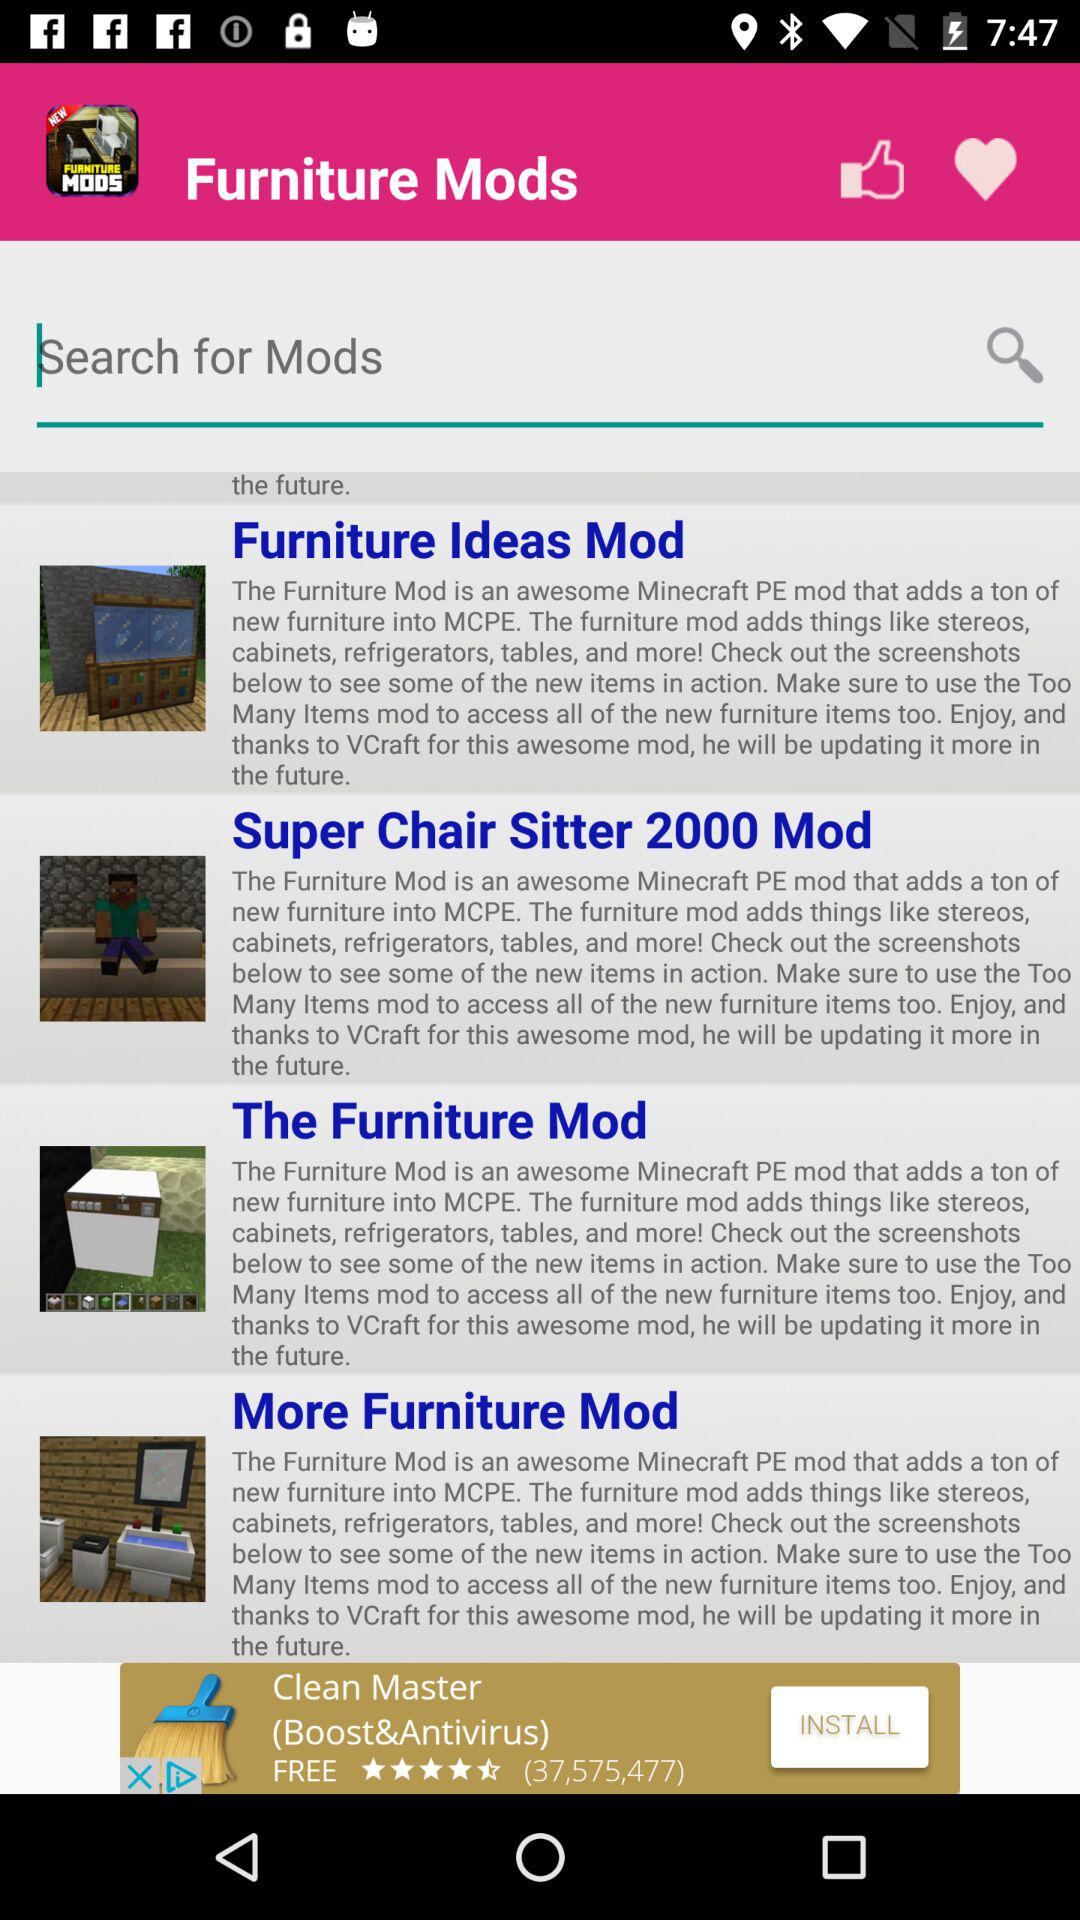What is the application name? The application name is "Furniture Mods". 